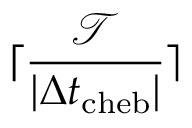Convert formula to latex. <formula><loc_0><loc_0><loc_500><loc_500>\lceil \frac { \mathcal { T } } { | \Delta t _ { c h e b } | } \rceil</formula> 